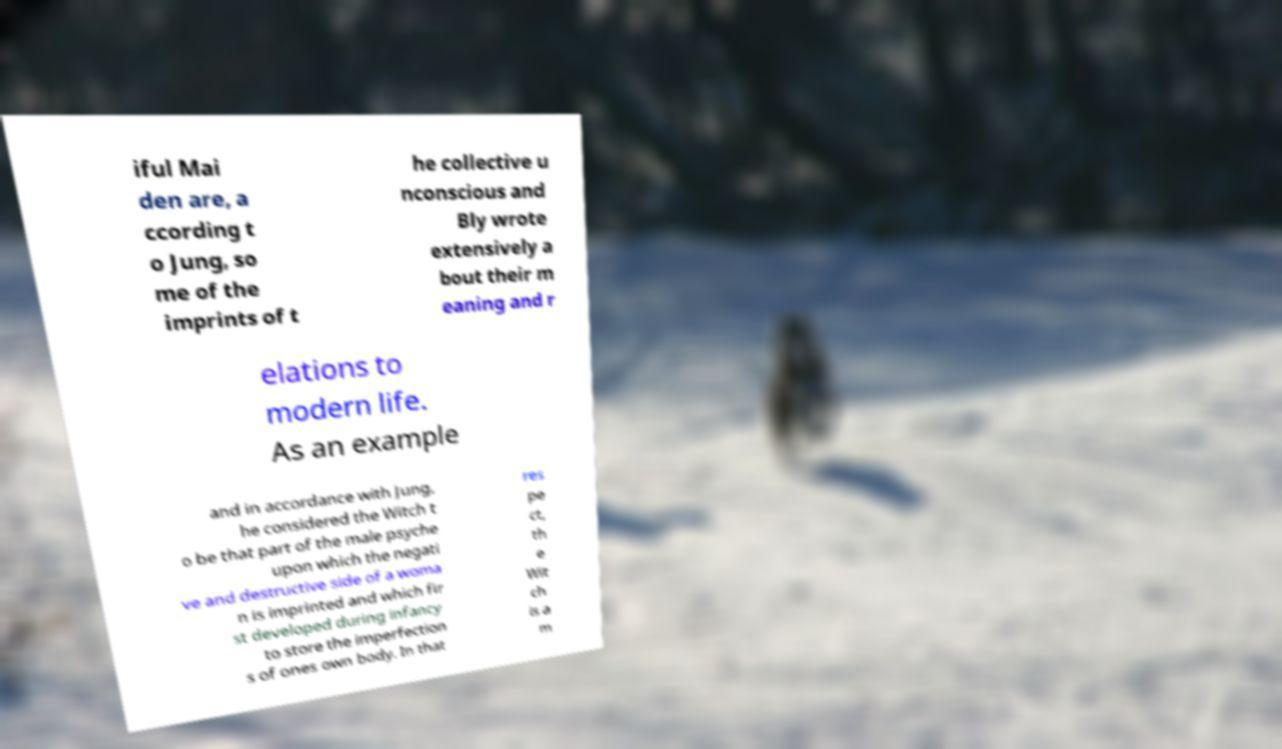I need the written content from this picture converted into text. Can you do that? iful Mai den are, a ccording t o Jung, so me of the imprints of t he collective u nconscious and Bly wrote extensively a bout their m eaning and r elations to modern life. As an example and in accordance with Jung, he considered the Witch t o be that part of the male psyche upon which the negati ve and destructive side of a woma n is imprinted and which fir st developed during infancy to store the imperfection s of ones own body. In that res pe ct, th e Wit ch is a m 